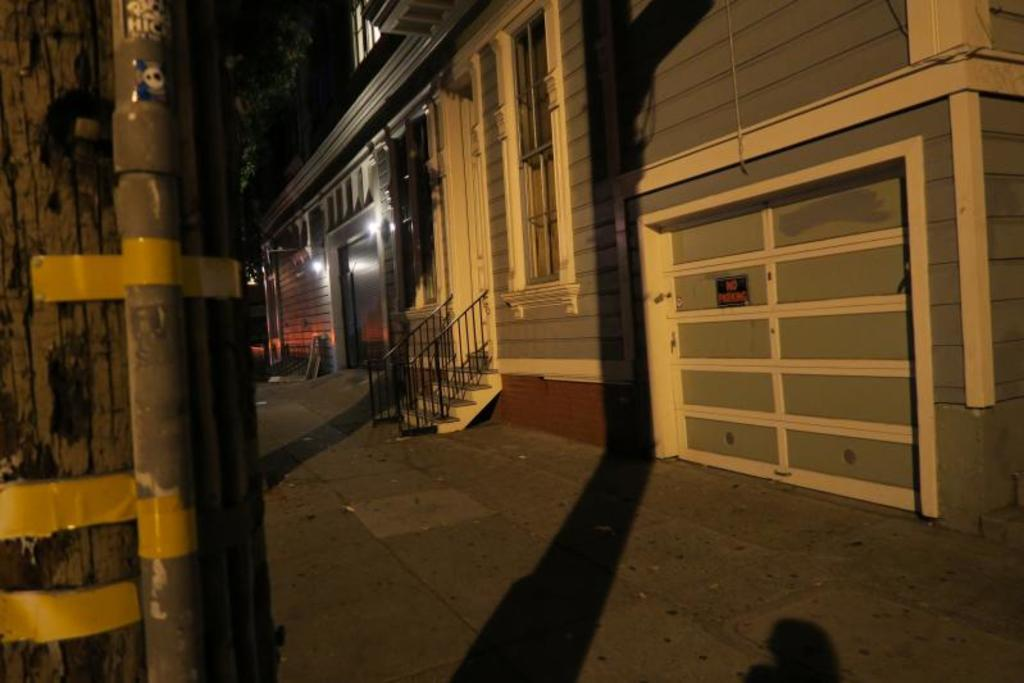What object is located on the left side of the image? There is a pipe on the left side of the image. What structure is in the middle of the image? There is a building in the middle of the image. What type of plant is visible at the top of the image? There appears to be a tree at the top of the image. What type of bells can be heard ringing in the image? There are no bells present in the image, and therefore no sound can be heard. What is the connection between the pipe and the tree in the image? There is no direct connection between the pipe and the tree in the image; they are separate objects. 